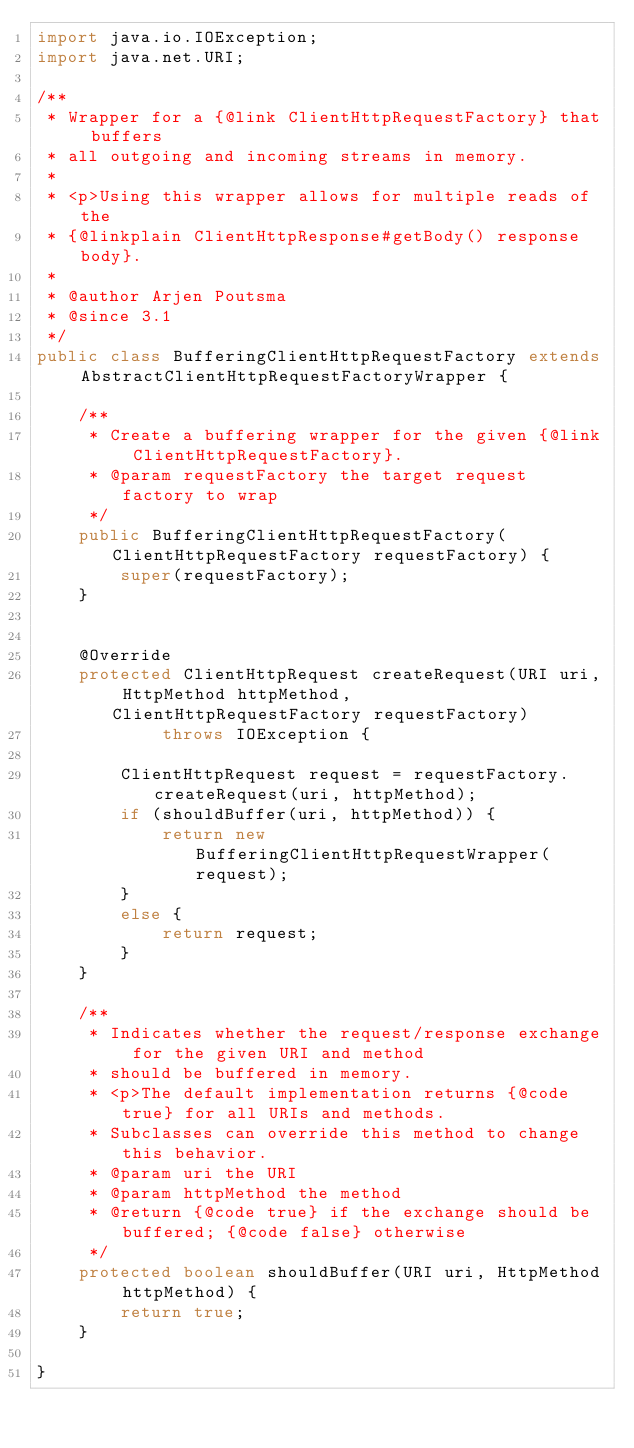<code> <loc_0><loc_0><loc_500><loc_500><_Java_>import java.io.IOException;
import java.net.URI;

/**
 * Wrapper for a {@link ClientHttpRequestFactory} that buffers
 * all outgoing and incoming streams in memory.
 *
 * <p>Using this wrapper allows for multiple reads of the
 * {@linkplain ClientHttpResponse#getBody() response body}.
 *
 * @author Arjen Poutsma
 * @since 3.1
 */
public class BufferingClientHttpRequestFactory extends AbstractClientHttpRequestFactoryWrapper {

	/**
	 * Create a buffering wrapper for the given {@link ClientHttpRequestFactory}.
	 * @param requestFactory the target request factory to wrap
	 */
	public BufferingClientHttpRequestFactory(ClientHttpRequestFactory requestFactory) {
		super(requestFactory);
	}


	@Override
	protected ClientHttpRequest createRequest(URI uri, HttpMethod httpMethod, ClientHttpRequestFactory requestFactory)
			throws IOException {

		ClientHttpRequest request = requestFactory.createRequest(uri, httpMethod);
		if (shouldBuffer(uri, httpMethod)) {
			return new BufferingClientHttpRequestWrapper(request);
		}
		else {
			return request;
		}
	}

	/**
	 * Indicates whether the request/response exchange for the given URI and method
	 * should be buffered in memory.
	 * <p>The default implementation returns {@code true} for all URIs and methods.
	 * Subclasses can override this method to change this behavior.
	 * @param uri the URI
	 * @param httpMethod the method
	 * @return {@code true} if the exchange should be buffered; {@code false} otherwise
	 */
	protected boolean shouldBuffer(URI uri, HttpMethod httpMethod) {
		return true;
	}

}
</code> 